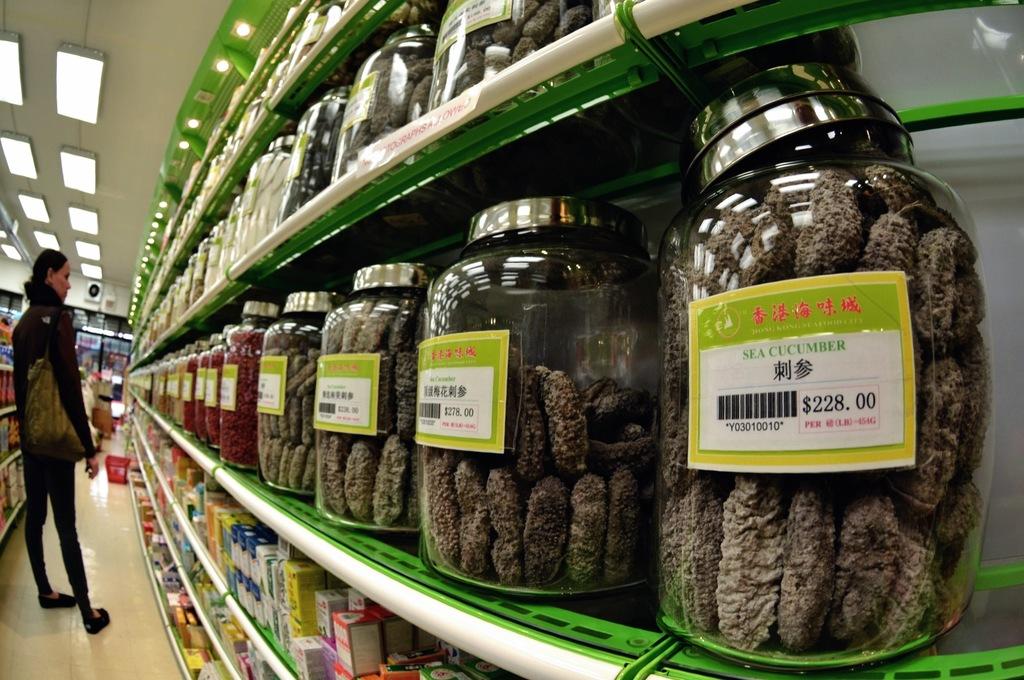What is in the foremost jar?
Provide a short and direct response. Sea cucumber. How much does the jar closest to the camera cost?
Keep it short and to the point. $228.00. 